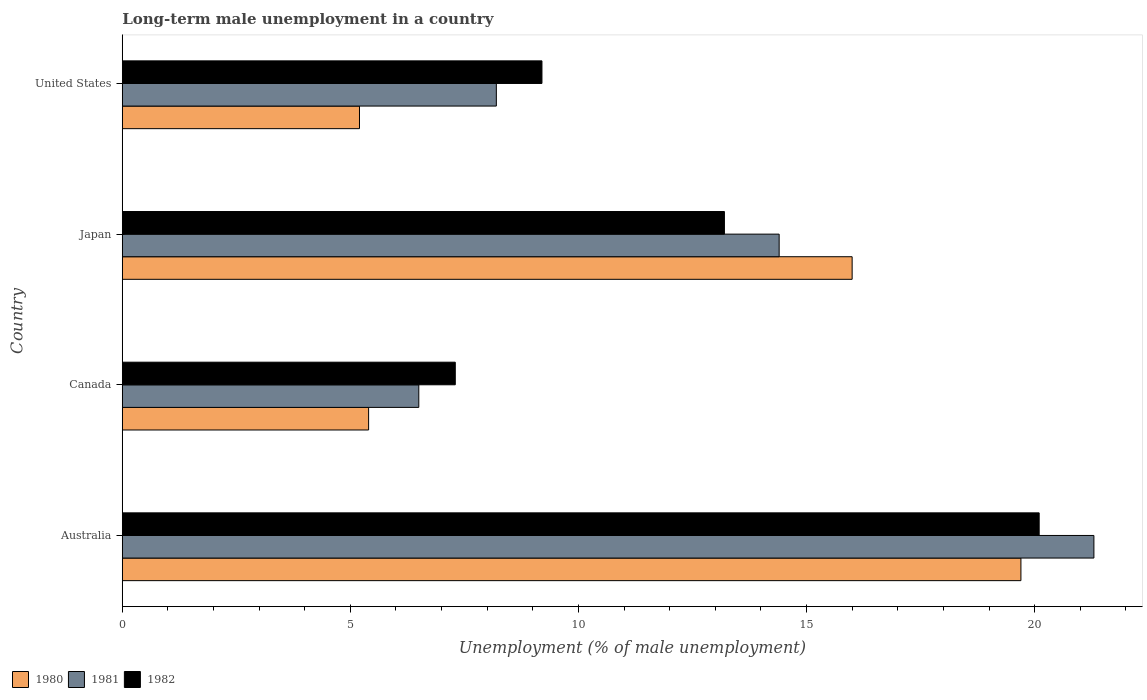How many groups of bars are there?
Ensure brevity in your answer.  4. Are the number of bars on each tick of the Y-axis equal?
Your answer should be compact. Yes. How many bars are there on the 1st tick from the bottom?
Provide a short and direct response. 3. What is the percentage of long-term unemployed male population in 1982 in Japan?
Offer a very short reply. 13.2. Across all countries, what is the maximum percentage of long-term unemployed male population in 1980?
Give a very brief answer. 19.7. Across all countries, what is the minimum percentage of long-term unemployed male population in 1982?
Your answer should be very brief. 7.3. In which country was the percentage of long-term unemployed male population in 1981 maximum?
Your answer should be compact. Australia. In which country was the percentage of long-term unemployed male population in 1981 minimum?
Your response must be concise. Canada. What is the total percentage of long-term unemployed male population in 1981 in the graph?
Ensure brevity in your answer.  50.4. What is the difference between the percentage of long-term unemployed male population in 1980 in Australia and that in Canada?
Your answer should be very brief. 14.3. What is the difference between the percentage of long-term unemployed male population in 1981 in Canada and the percentage of long-term unemployed male population in 1982 in Australia?
Ensure brevity in your answer.  -13.6. What is the average percentage of long-term unemployed male population in 1980 per country?
Provide a succinct answer. 11.58. What is the difference between the percentage of long-term unemployed male population in 1982 and percentage of long-term unemployed male population in 1981 in Japan?
Provide a succinct answer. -1.2. What is the ratio of the percentage of long-term unemployed male population in 1980 in Canada to that in United States?
Offer a terse response. 1.04. Is the percentage of long-term unemployed male population in 1982 in Australia less than that in Japan?
Provide a succinct answer. No. Is the difference between the percentage of long-term unemployed male population in 1982 in Canada and United States greater than the difference between the percentage of long-term unemployed male population in 1981 in Canada and United States?
Keep it short and to the point. No. What is the difference between the highest and the second highest percentage of long-term unemployed male population in 1981?
Give a very brief answer. 6.9. What is the difference between the highest and the lowest percentage of long-term unemployed male population in 1980?
Offer a terse response. 14.5. What does the 3rd bar from the top in Australia represents?
Ensure brevity in your answer.  1980. What does the 2nd bar from the bottom in Australia represents?
Keep it short and to the point. 1981. Is it the case that in every country, the sum of the percentage of long-term unemployed male population in 1980 and percentage of long-term unemployed male population in 1981 is greater than the percentage of long-term unemployed male population in 1982?
Ensure brevity in your answer.  Yes. How many bars are there?
Ensure brevity in your answer.  12. What is the difference between two consecutive major ticks on the X-axis?
Offer a terse response. 5. Are the values on the major ticks of X-axis written in scientific E-notation?
Provide a succinct answer. No. Does the graph contain any zero values?
Ensure brevity in your answer.  No. Does the graph contain grids?
Keep it short and to the point. No. How are the legend labels stacked?
Give a very brief answer. Horizontal. What is the title of the graph?
Make the answer very short. Long-term male unemployment in a country. What is the label or title of the X-axis?
Your response must be concise. Unemployment (% of male unemployment). What is the label or title of the Y-axis?
Keep it short and to the point. Country. What is the Unemployment (% of male unemployment) in 1980 in Australia?
Keep it short and to the point. 19.7. What is the Unemployment (% of male unemployment) of 1981 in Australia?
Make the answer very short. 21.3. What is the Unemployment (% of male unemployment) of 1982 in Australia?
Your answer should be compact. 20.1. What is the Unemployment (% of male unemployment) in 1980 in Canada?
Offer a very short reply. 5.4. What is the Unemployment (% of male unemployment) in 1982 in Canada?
Your answer should be compact. 7.3. What is the Unemployment (% of male unemployment) in 1981 in Japan?
Provide a short and direct response. 14.4. What is the Unemployment (% of male unemployment) of 1982 in Japan?
Offer a very short reply. 13.2. What is the Unemployment (% of male unemployment) of 1980 in United States?
Make the answer very short. 5.2. What is the Unemployment (% of male unemployment) of 1981 in United States?
Your answer should be very brief. 8.2. What is the Unemployment (% of male unemployment) of 1982 in United States?
Offer a terse response. 9.2. Across all countries, what is the maximum Unemployment (% of male unemployment) in 1980?
Provide a short and direct response. 19.7. Across all countries, what is the maximum Unemployment (% of male unemployment) of 1981?
Make the answer very short. 21.3. Across all countries, what is the maximum Unemployment (% of male unemployment) of 1982?
Provide a short and direct response. 20.1. Across all countries, what is the minimum Unemployment (% of male unemployment) in 1980?
Offer a terse response. 5.2. Across all countries, what is the minimum Unemployment (% of male unemployment) in 1981?
Give a very brief answer. 6.5. Across all countries, what is the minimum Unemployment (% of male unemployment) of 1982?
Provide a short and direct response. 7.3. What is the total Unemployment (% of male unemployment) in 1980 in the graph?
Your response must be concise. 46.3. What is the total Unemployment (% of male unemployment) of 1981 in the graph?
Provide a succinct answer. 50.4. What is the total Unemployment (% of male unemployment) in 1982 in the graph?
Provide a short and direct response. 49.8. What is the difference between the Unemployment (% of male unemployment) of 1980 in Australia and that in Canada?
Offer a very short reply. 14.3. What is the difference between the Unemployment (% of male unemployment) of 1982 in Australia and that in Canada?
Your answer should be very brief. 12.8. What is the difference between the Unemployment (% of male unemployment) in 1980 in Australia and that in Japan?
Give a very brief answer. 3.7. What is the difference between the Unemployment (% of male unemployment) of 1981 in Australia and that in United States?
Your answer should be very brief. 13.1. What is the difference between the Unemployment (% of male unemployment) of 1980 in Canada and that in Japan?
Give a very brief answer. -10.6. What is the difference between the Unemployment (% of male unemployment) in 1981 in Canada and that in Japan?
Your response must be concise. -7.9. What is the difference between the Unemployment (% of male unemployment) in 1981 in Canada and that in United States?
Your answer should be compact. -1.7. What is the difference between the Unemployment (% of male unemployment) in 1980 in Japan and that in United States?
Your response must be concise. 10.8. What is the difference between the Unemployment (% of male unemployment) in 1981 in Japan and that in United States?
Keep it short and to the point. 6.2. What is the difference between the Unemployment (% of male unemployment) of 1980 in Australia and the Unemployment (% of male unemployment) of 1981 in Canada?
Provide a short and direct response. 13.2. What is the difference between the Unemployment (% of male unemployment) of 1980 in Australia and the Unemployment (% of male unemployment) of 1982 in Japan?
Offer a terse response. 6.5. What is the difference between the Unemployment (% of male unemployment) in 1980 in Australia and the Unemployment (% of male unemployment) in 1981 in United States?
Offer a terse response. 11.5. What is the difference between the Unemployment (% of male unemployment) of 1980 in Australia and the Unemployment (% of male unemployment) of 1982 in United States?
Keep it short and to the point. 10.5. What is the difference between the Unemployment (% of male unemployment) of 1980 in Canada and the Unemployment (% of male unemployment) of 1981 in Japan?
Make the answer very short. -9. What is the difference between the Unemployment (% of male unemployment) in 1981 in Canada and the Unemployment (% of male unemployment) in 1982 in Japan?
Offer a very short reply. -6.7. What is the difference between the Unemployment (% of male unemployment) in 1981 in Canada and the Unemployment (% of male unemployment) in 1982 in United States?
Keep it short and to the point. -2.7. What is the difference between the Unemployment (% of male unemployment) of 1981 in Japan and the Unemployment (% of male unemployment) of 1982 in United States?
Ensure brevity in your answer.  5.2. What is the average Unemployment (% of male unemployment) of 1980 per country?
Keep it short and to the point. 11.57. What is the average Unemployment (% of male unemployment) of 1981 per country?
Keep it short and to the point. 12.6. What is the average Unemployment (% of male unemployment) of 1982 per country?
Keep it short and to the point. 12.45. What is the difference between the Unemployment (% of male unemployment) of 1981 and Unemployment (% of male unemployment) of 1982 in Australia?
Ensure brevity in your answer.  1.2. What is the difference between the Unemployment (% of male unemployment) of 1980 and Unemployment (% of male unemployment) of 1981 in Canada?
Ensure brevity in your answer.  -1.1. What is the difference between the Unemployment (% of male unemployment) of 1981 and Unemployment (% of male unemployment) of 1982 in Canada?
Ensure brevity in your answer.  -0.8. What is the difference between the Unemployment (% of male unemployment) of 1980 and Unemployment (% of male unemployment) of 1982 in Japan?
Offer a very short reply. 2.8. What is the difference between the Unemployment (% of male unemployment) in 1981 and Unemployment (% of male unemployment) in 1982 in Japan?
Offer a terse response. 1.2. What is the difference between the Unemployment (% of male unemployment) of 1980 and Unemployment (% of male unemployment) of 1981 in United States?
Offer a very short reply. -3. What is the difference between the Unemployment (% of male unemployment) of 1980 and Unemployment (% of male unemployment) of 1982 in United States?
Your answer should be compact. -4. What is the ratio of the Unemployment (% of male unemployment) of 1980 in Australia to that in Canada?
Keep it short and to the point. 3.65. What is the ratio of the Unemployment (% of male unemployment) in 1981 in Australia to that in Canada?
Your response must be concise. 3.28. What is the ratio of the Unemployment (% of male unemployment) of 1982 in Australia to that in Canada?
Provide a succinct answer. 2.75. What is the ratio of the Unemployment (% of male unemployment) of 1980 in Australia to that in Japan?
Make the answer very short. 1.23. What is the ratio of the Unemployment (% of male unemployment) in 1981 in Australia to that in Japan?
Offer a very short reply. 1.48. What is the ratio of the Unemployment (% of male unemployment) in 1982 in Australia to that in Japan?
Provide a succinct answer. 1.52. What is the ratio of the Unemployment (% of male unemployment) of 1980 in Australia to that in United States?
Keep it short and to the point. 3.79. What is the ratio of the Unemployment (% of male unemployment) in 1981 in Australia to that in United States?
Your response must be concise. 2.6. What is the ratio of the Unemployment (% of male unemployment) of 1982 in Australia to that in United States?
Ensure brevity in your answer.  2.18. What is the ratio of the Unemployment (% of male unemployment) of 1980 in Canada to that in Japan?
Offer a terse response. 0.34. What is the ratio of the Unemployment (% of male unemployment) of 1981 in Canada to that in Japan?
Provide a succinct answer. 0.45. What is the ratio of the Unemployment (% of male unemployment) of 1982 in Canada to that in Japan?
Offer a very short reply. 0.55. What is the ratio of the Unemployment (% of male unemployment) in 1980 in Canada to that in United States?
Provide a succinct answer. 1.04. What is the ratio of the Unemployment (% of male unemployment) of 1981 in Canada to that in United States?
Provide a succinct answer. 0.79. What is the ratio of the Unemployment (% of male unemployment) in 1982 in Canada to that in United States?
Offer a very short reply. 0.79. What is the ratio of the Unemployment (% of male unemployment) in 1980 in Japan to that in United States?
Give a very brief answer. 3.08. What is the ratio of the Unemployment (% of male unemployment) in 1981 in Japan to that in United States?
Your answer should be very brief. 1.76. What is the ratio of the Unemployment (% of male unemployment) of 1982 in Japan to that in United States?
Offer a very short reply. 1.43. What is the difference between the highest and the lowest Unemployment (% of male unemployment) in 1982?
Provide a short and direct response. 12.8. 